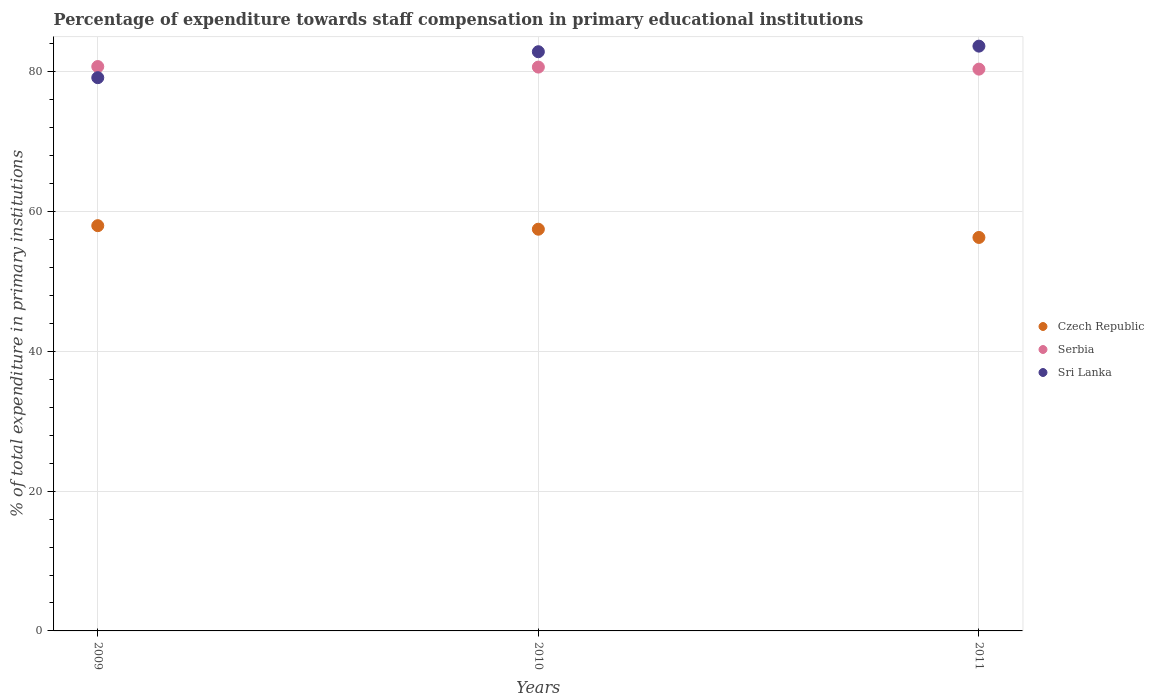How many different coloured dotlines are there?
Your answer should be very brief. 3. Is the number of dotlines equal to the number of legend labels?
Provide a short and direct response. Yes. What is the percentage of expenditure towards staff compensation in Sri Lanka in 2010?
Offer a terse response. 82.88. Across all years, what is the maximum percentage of expenditure towards staff compensation in Czech Republic?
Give a very brief answer. 57.99. Across all years, what is the minimum percentage of expenditure towards staff compensation in Czech Republic?
Your answer should be very brief. 56.31. In which year was the percentage of expenditure towards staff compensation in Czech Republic maximum?
Give a very brief answer. 2009. What is the total percentage of expenditure towards staff compensation in Sri Lanka in the graph?
Provide a short and direct response. 245.74. What is the difference between the percentage of expenditure towards staff compensation in Sri Lanka in 2010 and that in 2011?
Provide a succinct answer. -0.8. What is the difference between the percentage of expenditure towards staff compensation in Czech Republic in 2011 and the percentage of expenditure towards staff compensation in Serbia in 2009?
Your response must be concise. -24.46. What is the average percentage of expenditure towards staff compensation in Serbia per year?
Offer a very short reply. 80.61. In the year 2011, what is the difference between the percentage of expenditure towards staff compensation in Czech Republic and percentage of expenditure towards staff compensation in Serbia?
Your response must be concise. -24.09. What is the ratio of the percentage of expenditure towards staff compensation in Sri Lanka in 2010 to that in 2011?
Give a very brief answer. 0.99. Is the percentage of expenditure towards staff compensation in Serbia in 2009 less than that in 2011?
Your answer should be very brief. No. Is the difference between the percentage of expenditure towards staff compensation in Czech Republic in 2009 and 2011 greater than the difference between the percentage of expenditure towards staff compensation in Serbia in 2009 and 2011?
Your answer should be compact. Yes. What is the difference between the highest and the second highest percentage of expenditure towards staff compensation in Czech Republic?
Provide a succinct answer. 0.51. What is the difference between the highest and the lowest percentage of expenditure towards staff compensation in Serbia?
Make the answer very short. 0.37. In how many years, is the percentage of expenditure towards staff compensation in Serbia greater than the average percentage of expenditure towards staff compensation in Serbia taken over all years?
Your answer should be very brief. 2. Is the sum of the percentage of expenditure towards staff compensation in Sri Lanka in 2009 and 2010 greater than the maximum percentage of expenditure towards staff compensation in Czech Republic across all years?
Give a very brief answer. Yes. Does the percentage of expenditure towards staff compensation in Sri Lanka monotonically increase over the years?
Your answer should be very brief. Yes. Is the percentage of expenditure towards staff compensation in Serbia strictly greater than the percentage of expenditure towards staff compensation in Sri Lanka over the years?
Keep it short and to the point. No. Is the percentage of expenditure towards staff compensation in Czech Republic strictly less than the percentage of expenditure towards staff compensation in Serbia over the years?
Provide a short and direct response. Yes. How many dotlines are there?
Keep it short and to the point. 3. How many years are there in the graph?
Provide a short and direct response. 3. What is the difference between two consecutive major ticks on the Y-axis?
Offer a terse response. 20. Are the values on the major ticks of Y-axis written in scientific E-notation?
Offer a terse response. No. How are the legend labels stacked?
Provide a short and direct response. Vertical. What is the title of the graph?
Offer a very short reply. Percentage of expenditure towards staff compensation in primary educational institutions. What is the label or title of the Y-axis?
Offer a very short reply. % of total expenditure in primary institutions. What is the % of total expenditure in primary institutions in Czech Republic in 2009?
Your answer should be compact. 57.99. What is the % of total expenditure in primary institutions in Serbia in 2009?
Your response must be concise. 80.76. What is the % of total expenditure in primary institutions of Sri Lanka in 2009?
Ensure brevity in your answer.  79.17. What is the % of total expenditure in primary institutions in Czech Republic in 2010?
Your answer should be very brief. 57.49. What is the % of total expenditure in primary institutions of Serbia in 2010?
Offer a very short reply. 80.69. What is the % of total expenditure in primary institutions in Sri Lanka in 2010?
Your response must be concise. 82.88. What is the % of total expenditure in primary institutions in Czech Republic in 2011?
Your answer should be very brief. 56.31. What is the % of total expenditure in primary institutions in Serbia in 2011?
Provide a short and direct response. 80.39. What is the % of total expenditure in primary institutions of Sri Lanka in 2011?
Give a very brief answer. 83.68. Across all years, what is the maximum % of total expenditure in primary institutions in Czech Republic?
Make the answer very short. 57.99. Across all years, what is the maximum % of total expenditure in primary institutions of Serbia?
Your answer should be compact. 80.76. Across all years, what is the maximum % of total expenditure in primary institutions of Sri Lanka?
Offer a terse response. 83.68. Across all years, what is the minimum % of total expenditure in primary institutions of Czech Republic?
Provide a succinct answer. 56.31. Across all years, what is the minimum % of total expenditure in primary institutions in Serbia?
Provide a succinct answer. 80.39. Across all years, what is the minimum % of total expenditure in primary institutions in Sri Lanka?
Offer a very short reply. 79.17. What is the total % of total expenditure in primary institutions of Czech Republic in the graph?
Provide a short and direct response. 171.78. What is the total % of total expenditure in primary institutions in Serbia in the graph?
Ensure brevity in your answer.  241.84. What is the total % of total expenditure in primary institutions of Sri Lanka in the graph?
Give a very brief answer. 245.74. What is the difference between the % of total expenditure in primary institutions of Czech Republic in 2009 and that in 2010?
Ensure brevity in your answer.  0.51. What is the difference between the % of total expenditure in primary institutions of Serbia in 2009 and that in 2010?
Keep it short and to the point. 0.08. What is the difference between the % of total expenditure in primary institutions of Sri Lanka in 2009 and that in 2010?
Ensure brevity in your answer.  -3.71. What is the difference between the % of total expenditure in primary institutions in Czech Republic in 2009 and that in 2011?
Provide a succinct answer. 1.69. What is the difference between the % of total expenditure in primary institutions in Serbia in 2009 and that in 2011?
Your response must be concise. 0.37. What is the difference between the % of total expenditure in primary institutions of Sri Lanka in 2009 and that in 2011?
Provide a succinct answer. -4.51. What is the difference between the % of total expenditure in primary institutions of Czech Republic in 2010 and that in 2011?
Provide a short and direct response. 1.18. What is the difference between the % of total expenditure in primary institutions in Serbia in 2010 and that in 2011?
Make the answer very short. 0.29. What is the difference between the % of total expenditure in primary institutions in Sri Lanka in 2010 and that in 2011?
Offer a terse response. -0.8. What is the difference between the % of total expenditure in primary institutions in Czech Republic in 2009 and the % of total expenditure in primary institutions in Serbia in 2010?
Your answer should be compact. -22.69. What is the difference between the % of total expenditure in primary institutions of Czech Republic in 2009 and the % of total expenditure in primary institutions of Sri Lanka in 2010?
Ensure brevity in your answer.  -24.89. What is the difference between the % of total expenditure in primary institutions of Serbia in 2009 and the % of total expenditure in primary institutions of Sri Lanka in 2010?
Your answer should be compact. -2.12. What is the difference between the % of total expenditure in primary institutions in Czech Republic in 2009 and the % of total expenditure in primary institutions in Serbia in 2011?
Give a very brief answer. -22.4. What is the difference between the % of total expenditure in primary institutions of Czech Republic in 2009 and the % of total expenditure in primary institutions of Sri Lanka in 2011?
Provide a succinct answer. -25.69. What is the difference between the % of total expenditure in primary institutions in Serbia in 2009 and the % of total expenditure in primary institutions in Sri Lanka in 2011?
Provide a short and direct response. -2.92. What is the difference between the % of total expenditure in primary institutions in Czech Republic in 2010 and the % of total expenditure in primary institutions in Serbia in 2011?
Make the answer very short. -22.91. What is the difference between the % of total expenditure in primary institutions in Czech Republic in 2010 and the % of total expenditure in primary institutions in Sri Lanka in 2011?
Keep it short and to the point. -26.2. What is the difference between the % of total expenditure in primary institutions in Serbia in 2010 and the % of total expenditure in primary institutions in Sri Lanka in 2011?
Offer a very short reply. -3. What is the average % of total expenditure in primary institutions in Czech Republic per year?
Give a very brief answer. 57.26. What is the average % of total expenditure in primary institutions of Serbia per year?
Provide a short and direct response. 80.61. What is the average % of total expenditure in primary institutions of Sri Lanka per year?
Your response must be concise. 81.91. In the year 2009, what is the difference between the % of total expenditure in primary institutions of Czech Republic and % of total expenditure in primary institutions of Serbia?
Give a very brief answer. -22.77. In the year 2009, what is the difference between the % of total expenditure in primary institutions of Czech Republic and % of total expenditure in primary institutions of Sri Lanka?
Keep it short and to the point. -21.18. In the year 2009, what is the difference between the % of total expenditure in primary institutions of Serbia and % of total expenditure in primary institutions of Sri Lanka?
Ensure brevity in your answer.  1.59. In the year 2010, what is the difference between the % of total expenditure in primary institutions in Czech Republic and % of total expenditure in primary institutions in Serbia?
Ensure brevity in your answer.  -23.2. In the year 2010, what is the difference between the % of total expenditure in primary institutions in Czech Republic and % of total expenditure in primary institutions in Sri Lanka?
Give a very brief answer. -25.4. In the year 2010, what is the difference between the % of total expenditure in primary institutions in Serbia and % of total expenditure in primary institutions in Sri Lanka?
Keep it short and to the point. -2.2. In the year 2011, what is the difference between the % of total expenditure in primary institutions in Czech Republic and % of total expenditure in primary institutions in Serbia?
Offer a terse response. -24.09. In the year 2011, what is the difference between the % of total expenditure in primary institutions in Czech Republic and % of total expenditure in primary institutions in Sri Lanka?
Give a very brief answer. -27.38. In the year 2011, what is the difference between the % of total expenditure in primary institutions in Serbia and % of total expenditure in primary institutions in Sri Lanka?
Offer a terse response. -3.29. What is the ratio of the % of total expenditure in primary institutions of Czech Republic in 2009 to that in 2010?
Give a very brief answer. 1.01. What is the ratio of the % of total expenditure in primary institutions of Serbia in 2009 to that in 2010?
Your response must be concise. 1. What is the ratio of the % of total expenditure in primary institutions in Sri Lanka in 2009 to that in 2010?
Ensure brevity in your answer.  0.96. What is the ratio of the % of total expenditure in primary institutions in Czech Republic in 2009 to that in 2011?
Make the answer very short. 1.03. What is the ratio of the % of total expenditure in primary institutions of Sri Lanka in 2009 to that in 2011?
Offer a very short reply. 0.95. What is the ratio of the % of total expenditure in primary institutions in Czech Republic in 2010 to that in 2011?
Offer a very short reply. 1.02. What is the ratio of the % of total expenditure in primary institutions in Serbia in 2010 to that in 2011?
Your answer should be compact. 1. What is the ratio of the % of total expenditure in primary institutions of Sri Lanka in 2010 to that in 2011?
Offer a very short reply. 0.99. What is the difference between the highest and the second highest % of total expenditure in primary institutions of Czech Republic?
Offer a terse response. 0.51. What is the difference between the highest and the second highest % of total expenditure in primary institutions of Serbia?
Provide a short and direct response. 0.08. What is the difference between the highest and the second highest % of total expenditure in primary institutions in Sri Lanka?
Give a very brief answer. 0.8. What is the difference between the highest and the lowest % of total expenditure in primary institutions of Czech Republic?
Make the answer very short. 1.69. What is the difference between the highest and the lowest % of total expenditure in primary institutions in Serbia?
Keep it short and to the point. 0.37. What is the difference between the highest and the lowest % of total expenditure in primary institutions of Sri Lanka?
Provide a short and direct response. 4.51. 